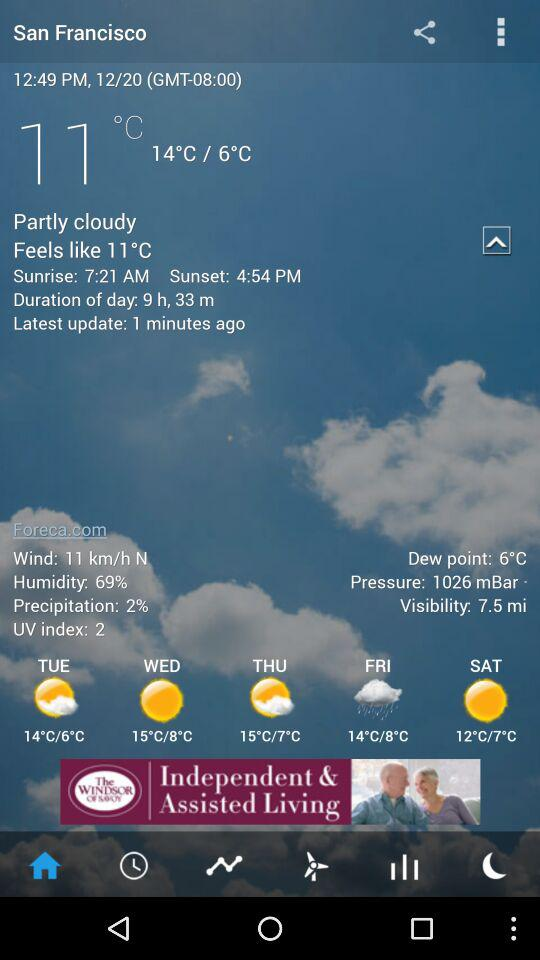What is the current temperature? The current temperature is 11°C. 